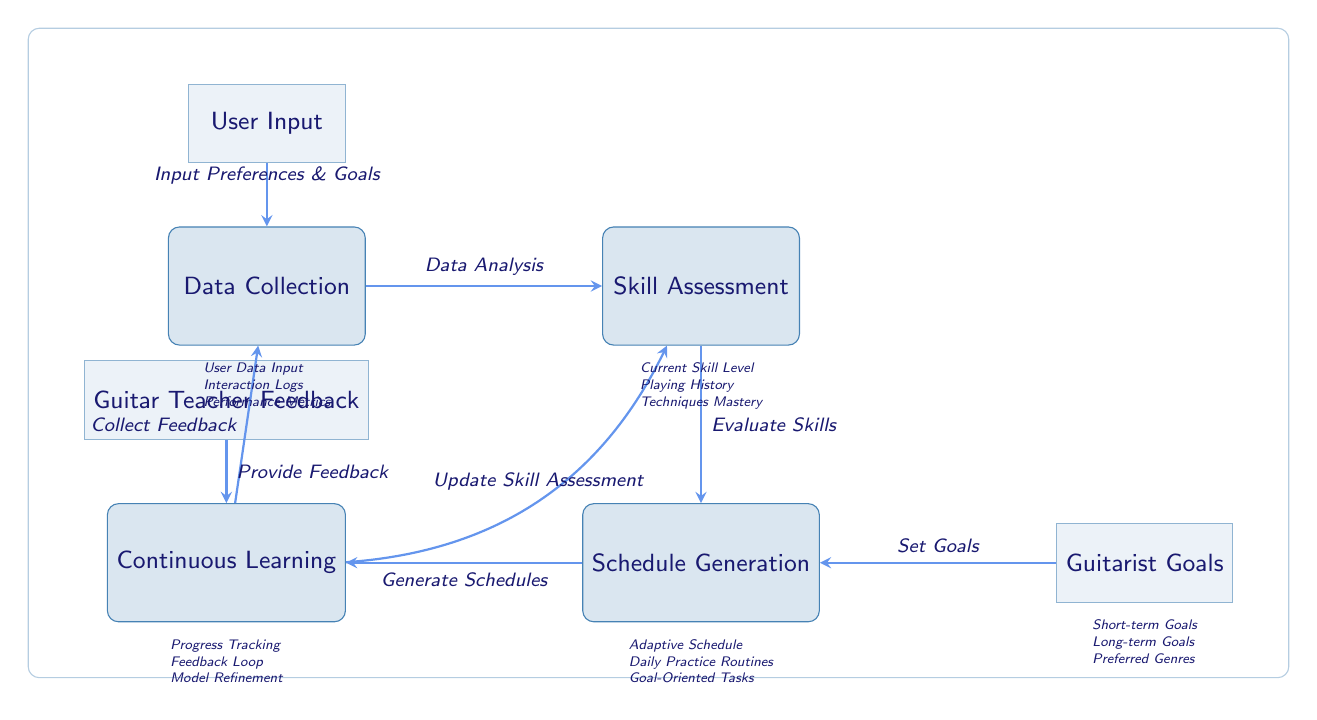What are the main components of the diagram? The diagram consists of four main components: Data Collection, Skill Assessment, Schedule Generation, and Continuous Learning. These nodes represent the primary stages in creating personalized practice schedules for guitarists.
Answer: Data Collection, Skill Assessment, Schedule Generation, Continuous Learning How many subnodes are there in the diagram? The diagram contains three subnodes: User Input, Goals, and Guitar Teacher Feedback. These subnodes provide additional details related to the main components.
Answer: Three What is the relationship between Skill Assessment and Schedule Generation? The skill assessment evaluates the guitarist's skills, which is a prerequisite for the schedule generation process. The output from skill assessment directly influences the generated practice schedule.
Answer: Evaluate Skills What type of feedback is collected in the Continuous Learning phase? In the Continuous Learning phase, feedback is collected from both user interactions (such as progress tracking) and feedback provided by a guitar teacher. This helps in refining the model continually.
Answer: Provide Feedback What inputs are required for Data Collection? Data Collection requires input preferences and goals from the user, which guides the system in understanding the guitarist's needs and expectations. This user input is essential for tailoring the practice schedule.
Answer: Input Preferences & Goals What happens after Schedule Generation? After Schedule Generation, the generated practice schedules are used in the Continuous Learning phase, where feedback is collected to refine the system and update the skill assessment based on progress and user experience.
Answer: Generate Schedules How does the guitar teacher contribute to the system? The guitar teacher provides feedback that is integrated into the Continuous Learning phase, which allows for improving the skill assessment and ensuring that the guitarist's practice aligns with expert recommendations.
Answer: Provide Feedback What kind of goals are set in the Schedule Generation phase? During the Schedule Generation phase, both short-term and long-term goals are considered, along with preferred genres, to ensure that the generated schedules meet the guitarist's personal aspirations.
Answer: Short-term Goals, Long-term Goals, Preferred Genres What is the feedback loop in the Continuous Learning phase? The feedback loop in the Continuous Learning phase refers to the iterative process where user feedback is collected, analyzed, and then used to improve the skill assessment, ultimately enhancing the practice schedule generation.
Answer: Collect Feedback 